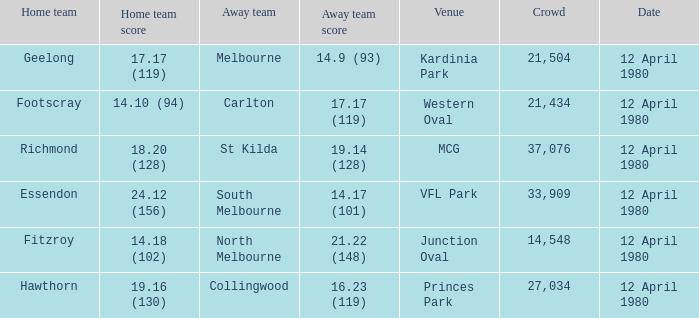Who was North Melbourne's home opponent? Fitzroy. 